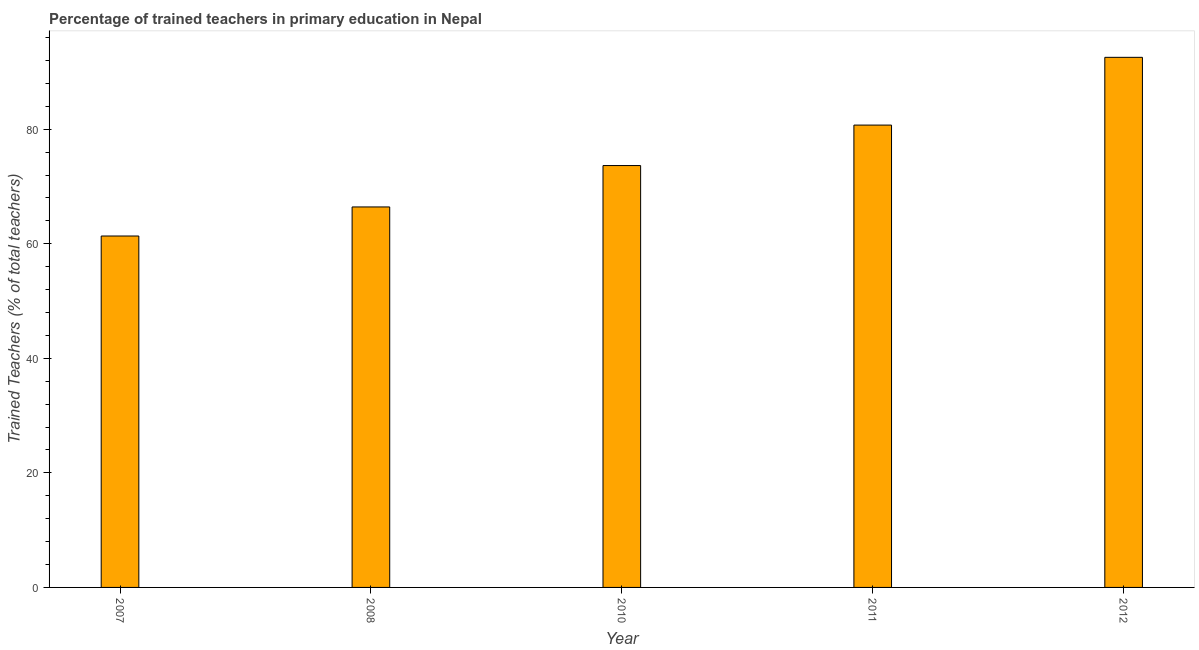Does the graph contain any zero values?
Offer a very short reply. No. What is the title of the graph?
Your response must be concise. Percentage of trained teachers in primary education in Nepal. What is the label or title of the X-axis?
Keep it short and to the point. Year. What is the label or title of the Y-axis?
Offer a very short reply. Trained Teachers (% of total teachers). What is the percentage of trained teachers in 2008?
Keep it short and to the point. 66.44. Across all years, what is the maximum percentage of trained teachers?
Offer a terse response. 92.56. Across all years, what is the minimum percentage of trained teachers?
Your answer should be compact. 61.36. In which year was the percentage of trained teachers minimum?
Your answer should be very brief. 2007. What is the sum of the percentage of trained teachers?
Your response must be concise. 374.74. What is the difference between the percentage of trained teachers in 2007 and 2011?
Offer a very short reply. -19.37. What is the average percentage of trained teachers per year?
Provide a succinct answer. 74.95. What is the median percentage of trained teachers?
Your answer should be very brief. 73.66. Do a majority of the years between 2011 and 2010 (inclusive) have percentage of trained teachers greater than 88 %?
Keep it short and to the point. No. What is the ratio of the percentage of trained teachers in 2010 to that in 2011?
Your answer should be compact. 0.91. Is the percentage of trained teachers in 2010 less than that in 2011?
Offer a very short reply. Yes. What is the difference between the highest and the second highest percentage of trained teachers?
Your response must be concise. 11.83. Is the sum of the percentage of trained teachers in 2010 and 2011 greater than the maximum percentage of trained teachers across all years?
Make the answer very short. Yes. What is the difference between the highest and the lowest percentage of trained teachers?
Your answer should be compact. 31.2. How many bars are there?
Ensure brevity in your answer.  5. Are all the bars in the graph horizontal?
Keep it short and to the point. No. Are the values on the major ticks of Y-axis written in scientific E-notation?
Your answer should be compact. No. What is the Trained Teachers (% of total teachers) of 2007?
Your answer should be compact. 61.36. What is the Trained Teachers (% of total teachers) of 2008?
Give a very brief answer. 66.44. What is the Trained Teachers (% of total teachers) of 2010?
Give a very brief answer. 73.66. What is the Trained Teachers (% of total teachers) in 2011?
Provide a short and direct response. 80.73. What is the Trained Teachers (% of total teachers) of 2012?
Make the answer very short. 92.56. What is the difference between the Trained Teachers (% of total teachers) in 2007 and 2008?
Your response must be concise. -5.08. What is the difference between the Trained Teachers (% of total teachers) in 2007 and 2010?
Provide a succinct answer. -12.3. What is the difference between the Trained Teachers (% of total teachers) in 2007 and 2011?
Provide a short and direct response. -19.37. What is the difference between the Trained Teachers (% of total teachers) in 2007 and 2012?
Provide a succinct answer. -31.2. What is the difference between the Trained Teachers (% of total teachers) in 2008 and 2010?
Give a very brief answer. -7.22. What is the difference between the Trained Teachers (% of total teachers) in 2008 and 2011?
Offer a terse response. -14.29. What is the difference between the Trained Teachers (% of total teachers) in 2008 and 2012?
Provide a short and direct response. -26.12. What is the difference between the Trained Teachers (% of total teachers) in 2010 and 2011?
Keep it short and to the point. -7.07. What is the difference between the Trained Teachers (% of total teachers) in 2010 and 2012?
Your response must be concise. -18.9. What is the difference between the Trained Teachers (% of total teachers) in 2011 and 2012?
Provide a succinct answer. -11.83. What is the ratio of the Trained Teachers (% of total teachers) in 2007 to that in 2008?
Keep it short and to the point. 0.92. What is the ratio of the Trained Teachers (% of total teachers) in 2007 to that in 2010?
Offer a terse response. 0.83. What is the ratio of the Trained Teachers (% of total teachers) in 2007 to that in 2011?
Offer a terse response. 0.76. What is the ratio of the Trained Teachers (% of total teachers) in 2007 to that in 2012?
Make the answer very short. 0.66. What is the ratio of the Trained Teachers (% of total teachers) in 2008 to that in 2010?
Your response must be concise. 0.9. What is the ratio of the Trained Teachers (% of total teachers) in 2008 to that in 2011?
Your answer should be very brief. 0.82. What is the ratio of the Trained Teachers (% of total teachers) in 2008 to that in 2012?
Keep it short and to the point. 0.72. What is the ratio of the Trained Teachers (% of total teachers) in 2010 to that in 2011?
Your answer should be very brief. 0.91. What is the ratio of the Trained Teachers (% of total teachers) in 2010 to that in 2012?
Offer a terse response. 0.8. What is the ratio of the Trained Teachers (% of total teachers) in 2011 to that in 2012?
Offer a terse response. 0.87. 